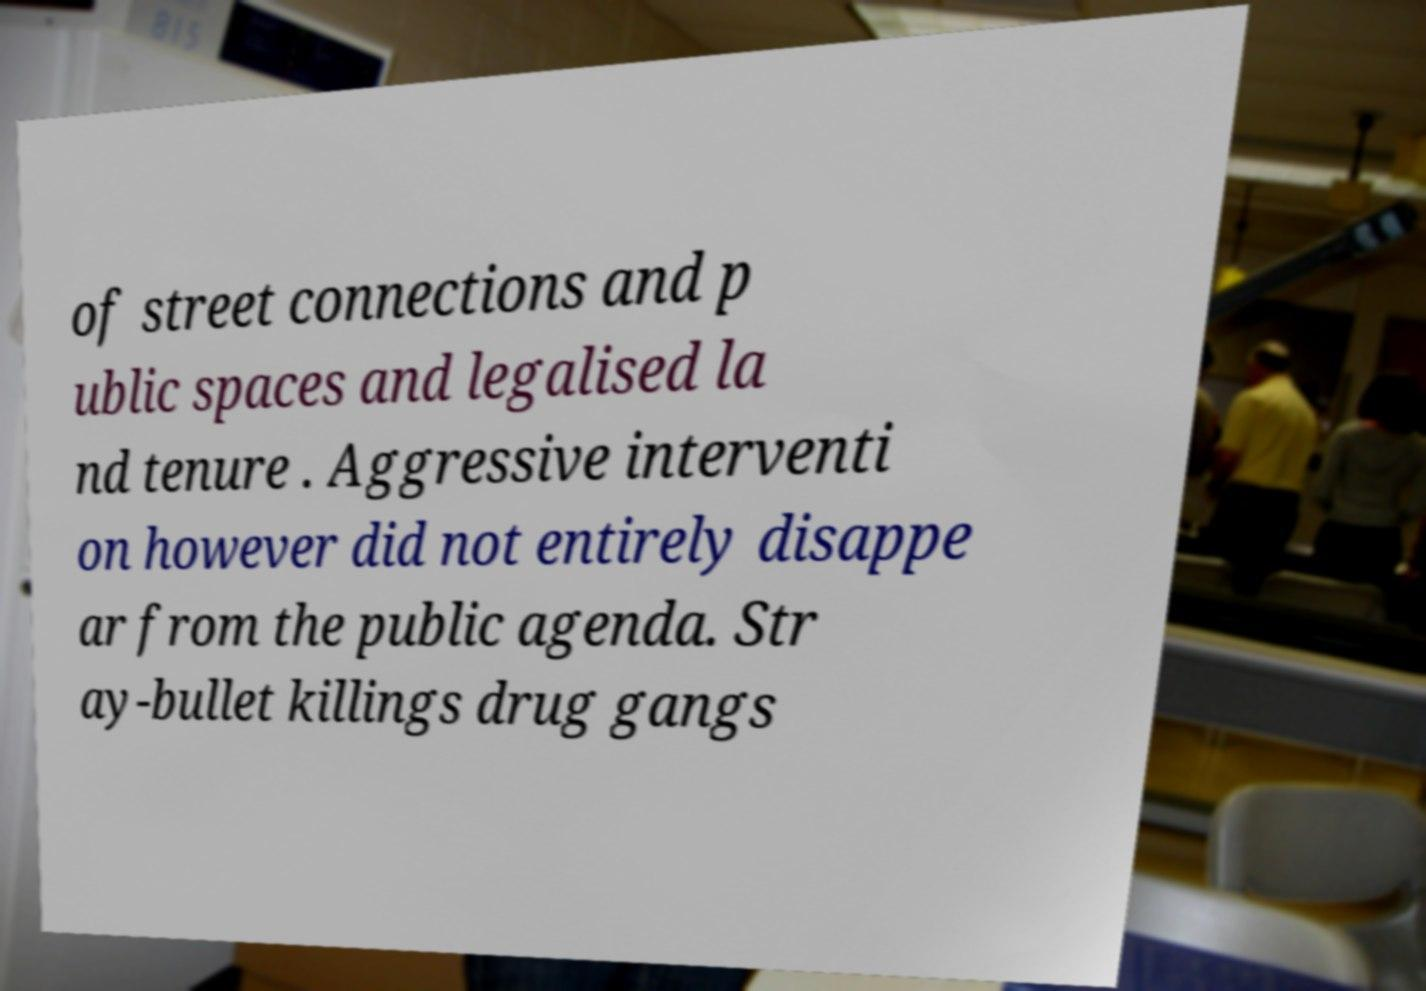What messages or text are displayed in this image? I need them in a readable, typed format. of street connections and p ublic spaces and legalised la nd tenure . Aggressive interventi on however did not entirely disappe ar from the public agenda. Str ay-bullet killings drug gangs 